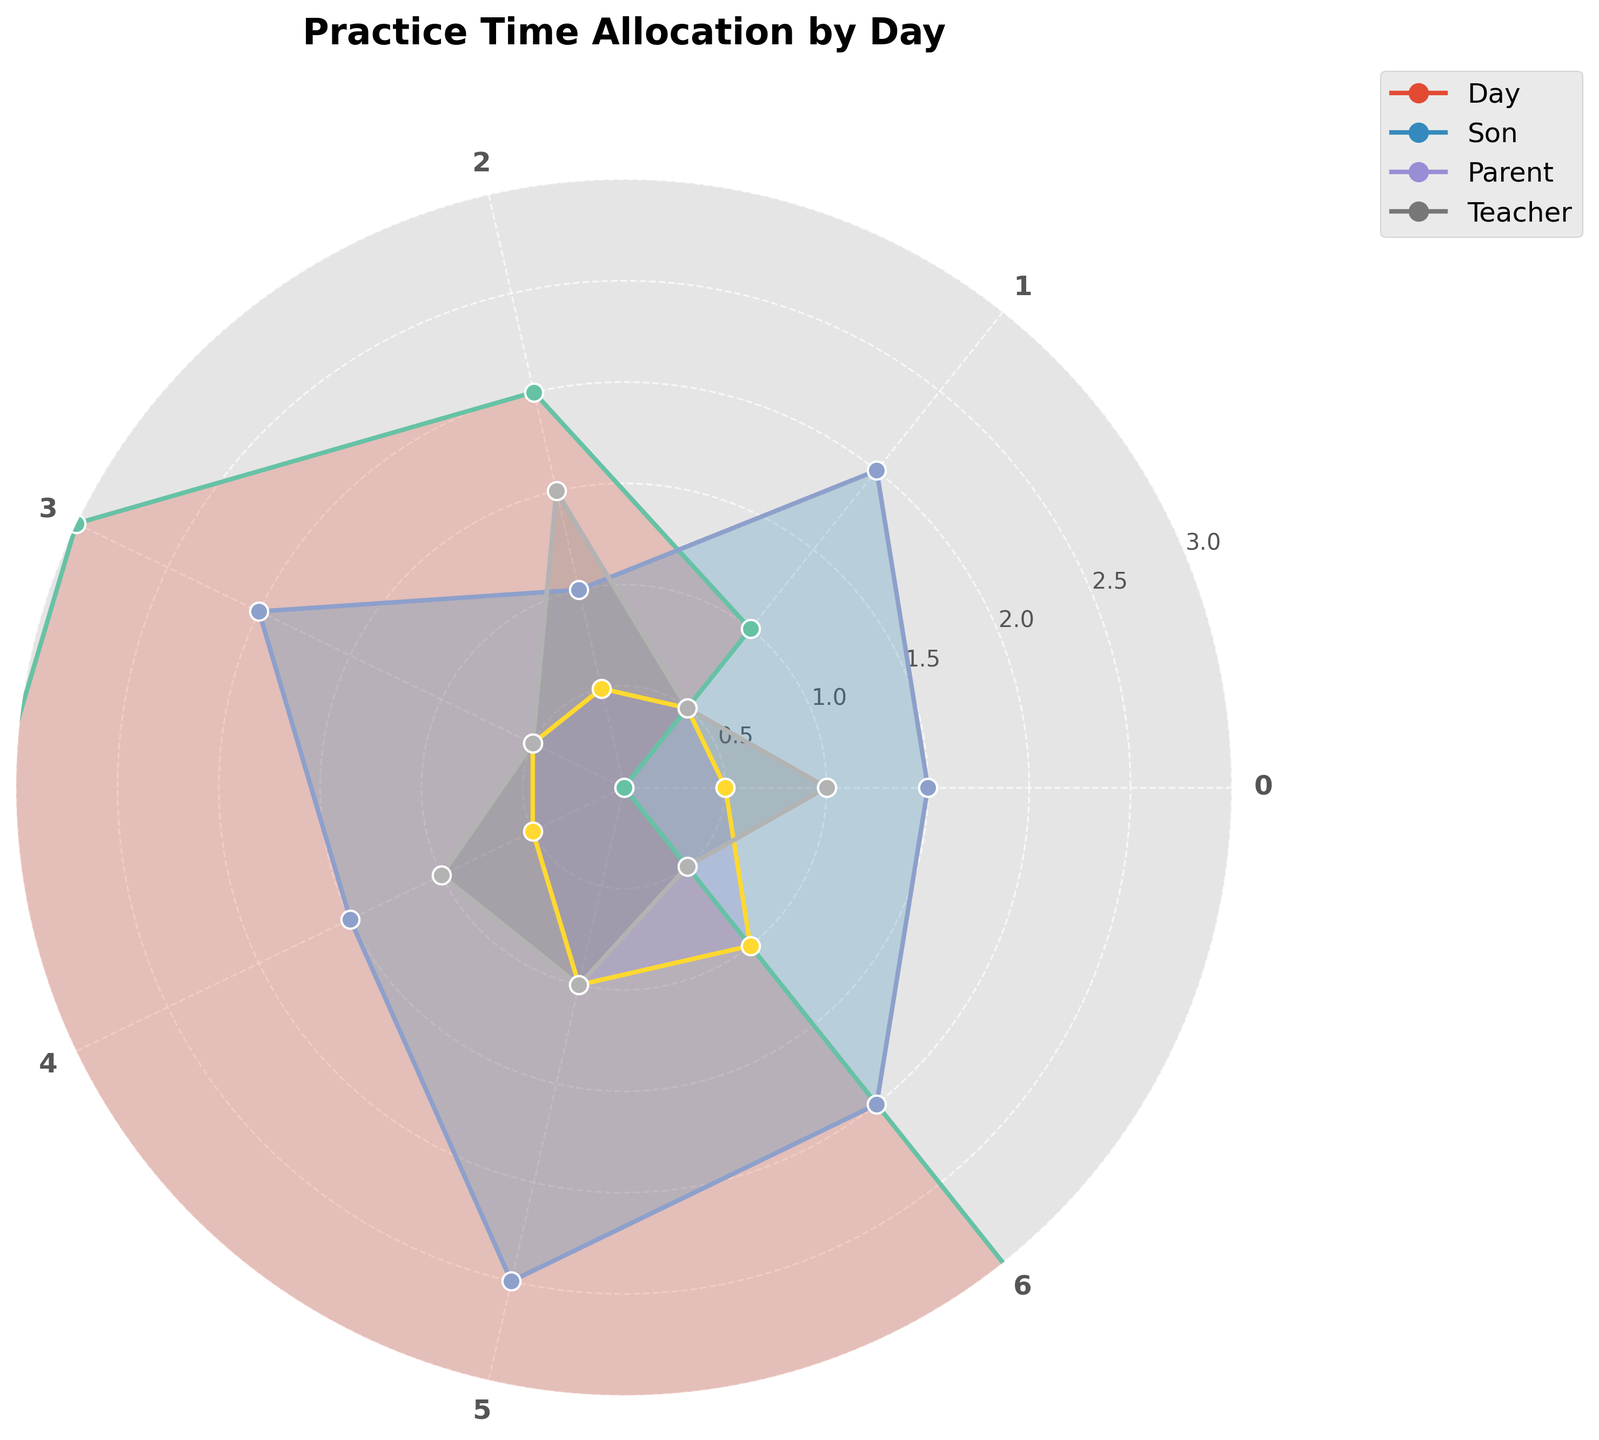what is the title of the radar chart? The title is typically located at the top of the chart and provides a brief description of what the chart represents.
Answer: Practice Time Allocation by Day Which day has the highest practice time for the Son? Look for the day where the Son's practice time reaches its peak on the radar plot.
Answer: Saturday Which day has the least practice time for the Teacher? Identify the point where the Teacher's practice time is at its minimum.
Answer: Tuesday What's the difference in practice time between Monday and Thursday for the Son? Find the practice time for the Son on Monday (1.5 hours) and on Thursday (2.0 hours), then calculate the difference (2.0 - 1.5).
Answer: 0.5 hours Which day does the Parent practice the most compared to other days? Identify the day where the Parent's practice time is at its peak on the radar plot.
Answer: Saturday What is the average practice time for the Teacher across the week? Sum the Teacher's practice times for all days (1.0 + 0.5 + 1.5 + 0.5 + 1.0 + 1.0 + 0.5 = 6.0), then divide by the number of days (7).
Answer: 0.86 hours On which day do all three groups have the same practice time? Look for a point on the radar chart where all three groups intersect at the same value.
Answer: This day is not present; the practice times vary How many days does the Son practice more than the Parent? Compare the Son's practice time with the Parent's for each day and count the days where the Son's values are higher.
Answer: 5 days On which day does the difference between the Son's and the Teacher's practice time reach the maximum? Calculate the differences for each day, then identify the maximum difference.
Answer: Wednesday (1.0 hours) Which two days does the Parent practice for an equal amount of time? Identify points on the radar plot where the Parent's practice time is the same.
Answer: Monday and Tuesday 